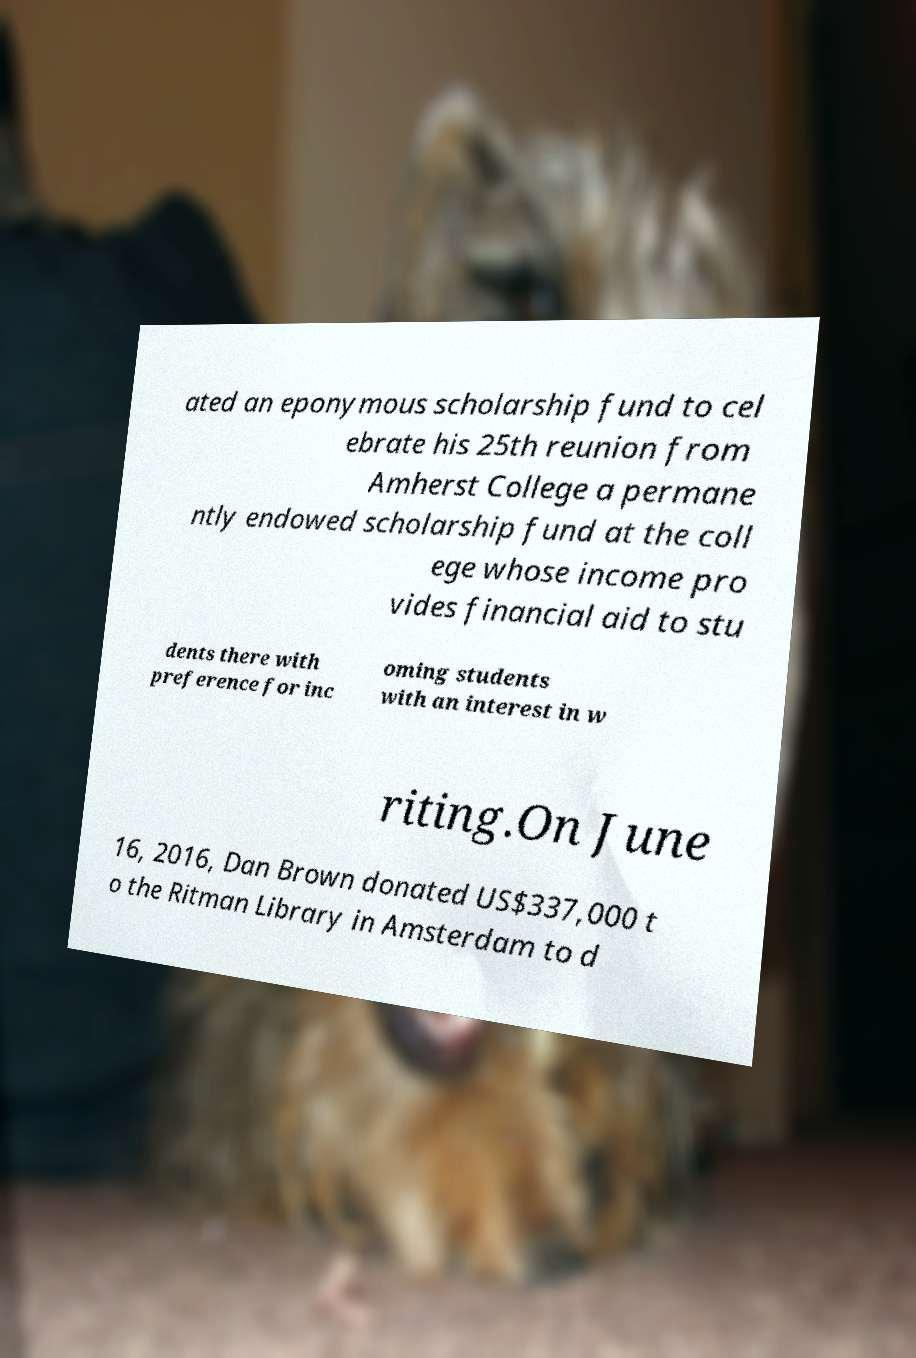Can you read and provide the text displayed in the image?This photo seems to have some interesting text. Can you extract and type it out for me? ated an eponymous scholarship fund to cel ebrate his 25th reunion from Amherst College a permane ntly endowed scholarship fund at the coll ege whose income pro vides financial aid to stu dents there with preference for inc oming students with an interest in w riting.On June 16, 2016, Dan Brown donated US$337,000 t o the Ritman Library in Amsterdam to d 